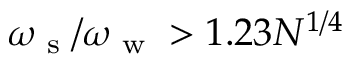Convert formula to latex. <formula><loc_0><loc_0><loc_500><loc_500>\omega _ { s } / \omega _ { w } > 1 . 2 3 N ^ { 1 / 4 }</formula> 